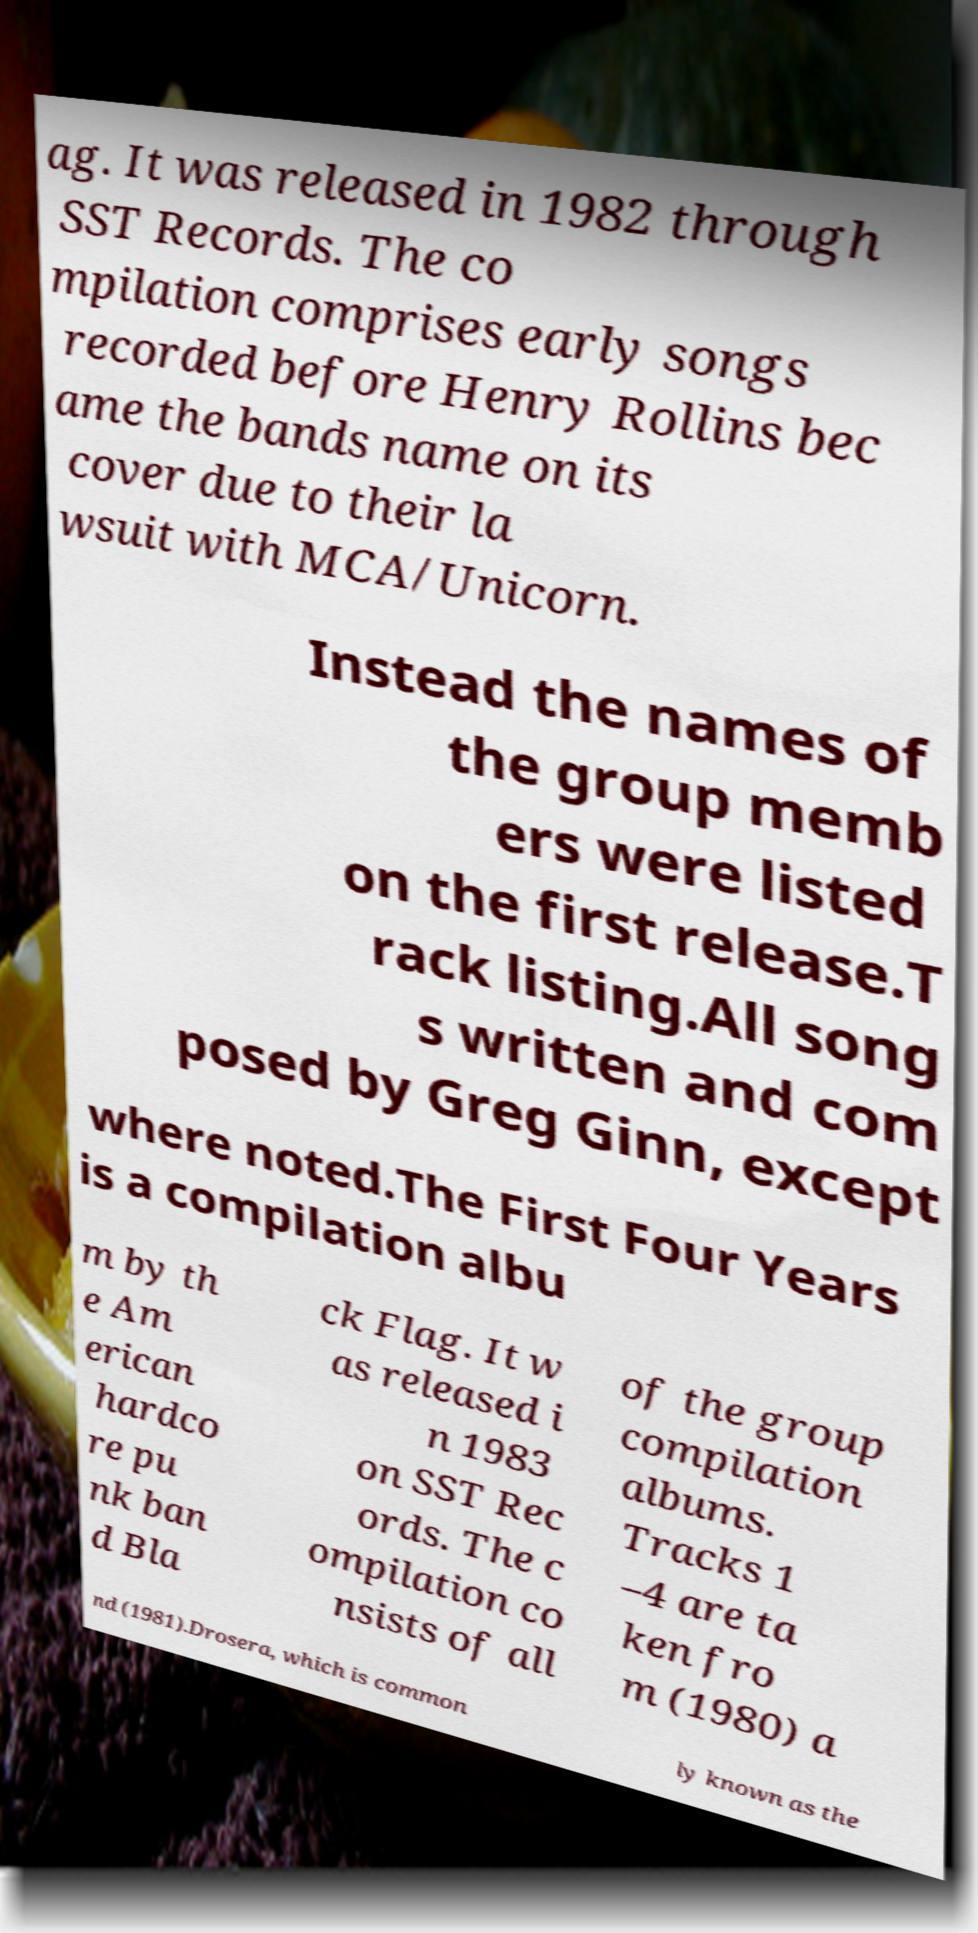Please read and relay the text visible in this image. What does it say? ag. It was released in 1982 through SST Records. The co mpilation comprises early songs recorded before Henry Rollins bec ame the bands name on its cover due to their la wsuit with MCA/Unicorn. Instead the names of the group memb ers were listed on the first release.T rack listing.All song s written and com posed by Greg Ginn, except where noted.The First Four Years is a compilation albu m by th e Am erican hardco re pu nk ban d Bla ck Flag. It w as released i n 1983 on SST Rec ords. The c ompilation co nsists of all of the group compilation albums. Tracks 1 –4 are ta ken fro m (1980) a nd (1981).Drosera, which is common ly known as the 